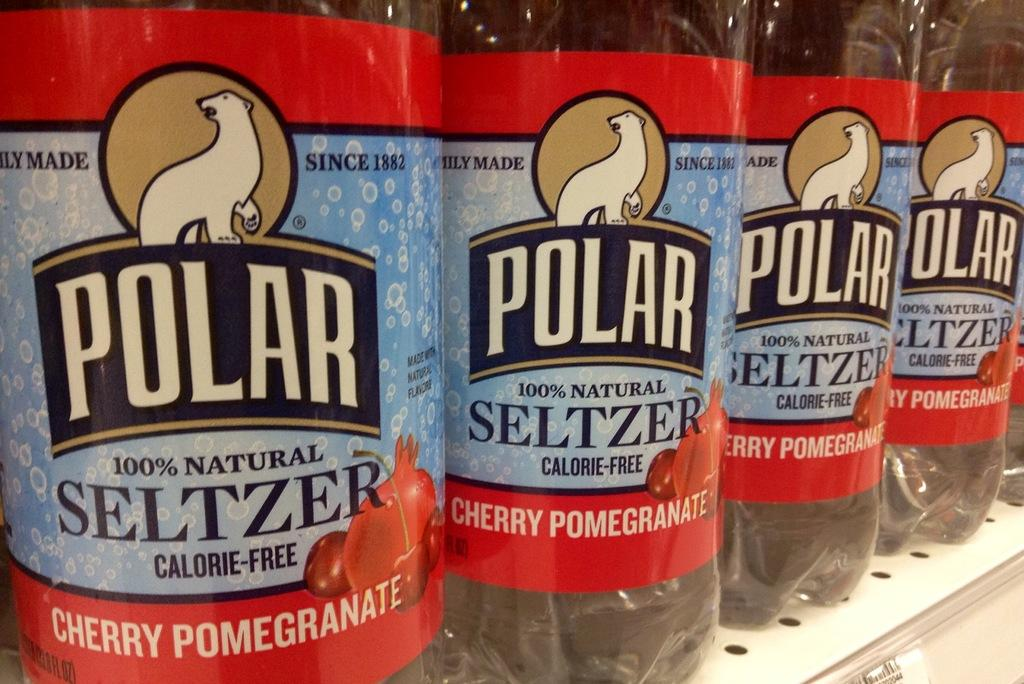<image>
Describe the image concisely. Four bottles of cherry pomegranate Polar seltzer sit in a row. 